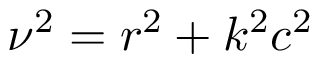<formula> <loc_0><loc_0><loc_500><loc_500>\nu ^ { 2 } = r ^ { 2 } + k ^ { 2 } c ^ { 2 }</formula> 